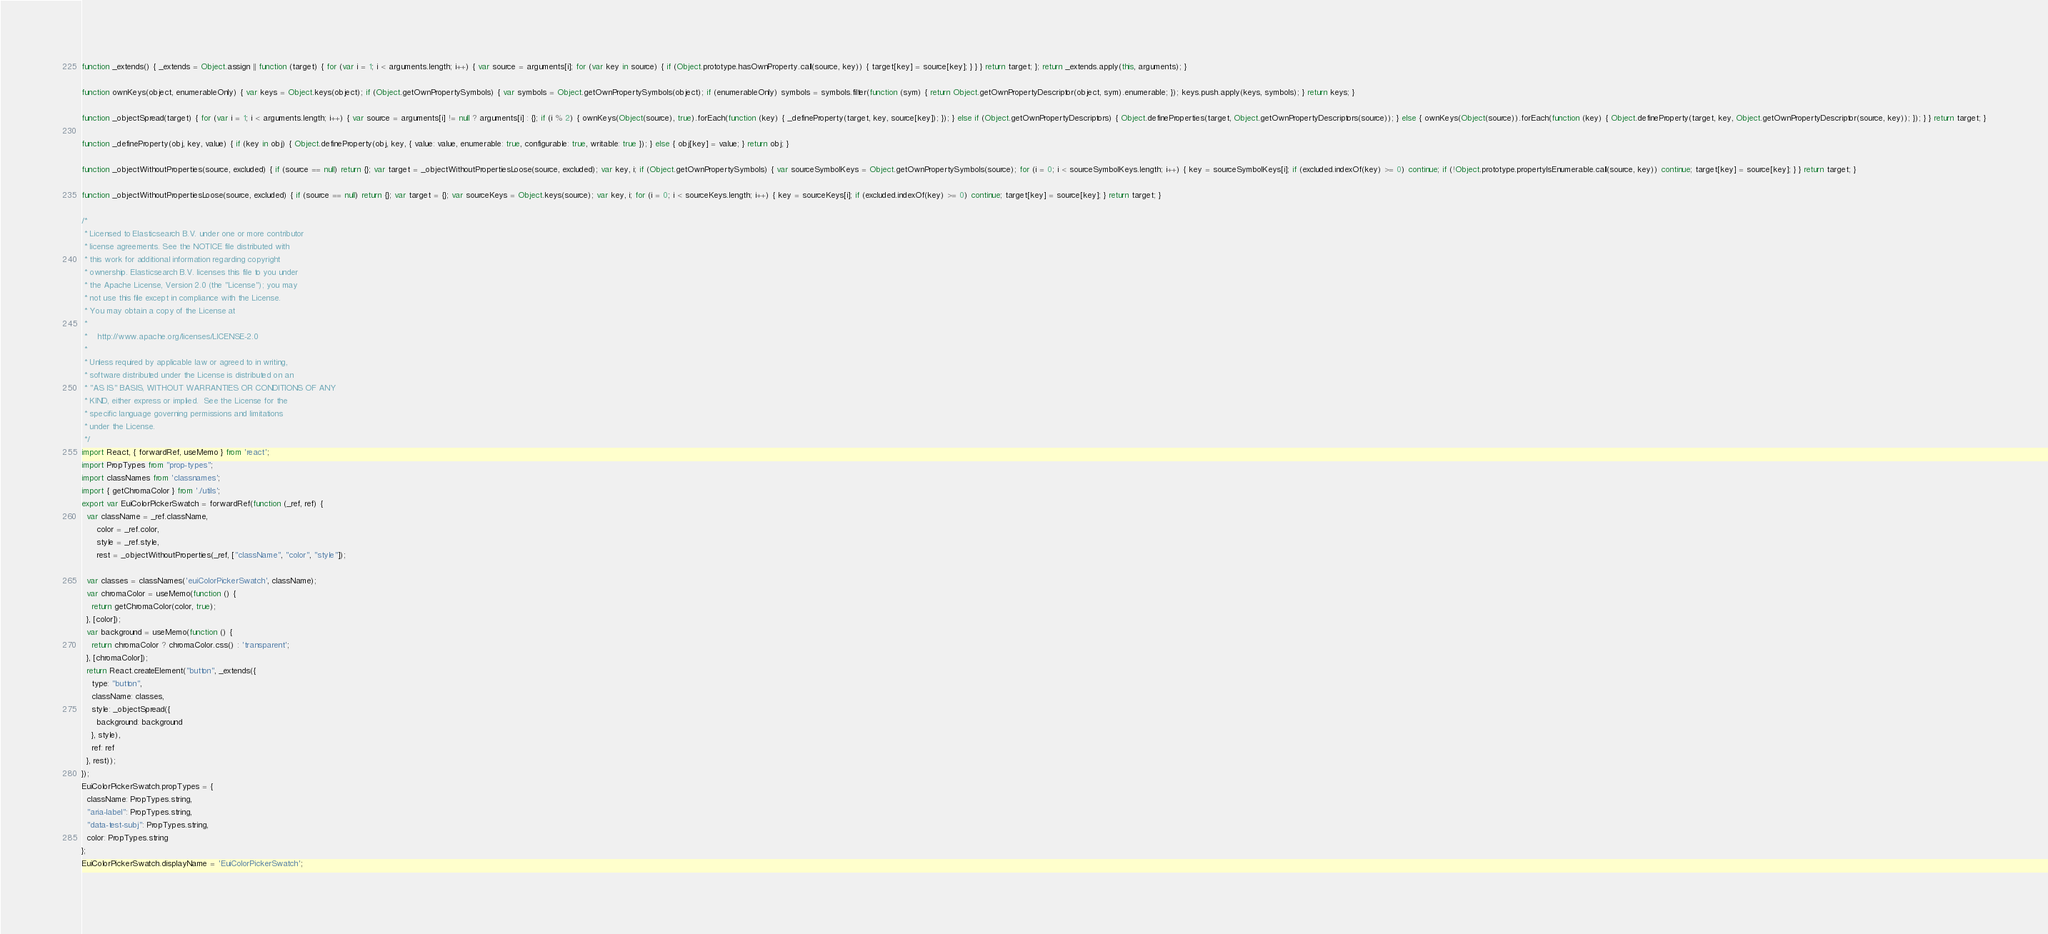<code> <loc_0><loc_0><loc_500><loc_500><_JavaScript_>function _extends() { _extends = Object.assign || function (target) { for (var i = 1; i < arguments.length; i++) { var source = arguments[i]; for (var key in source) { if (Object.prototype.hasOwnProperty.call(source, key)) { target[key] = source[key]; } } } return target; }; return _extends.apply(this, arguments); }

function ownKeys(object, enumerableOnly) { var keys = Object.keys(object); if (Object.getOwnPropertySymbols) { var symbols = Object.getOwnPropertySymbols(object); if (enumerableOnly) symbols = symbols.filter(function (sym) { return Object.getOwnPropertyDescriptor(object, sym).enumerable; }); keys.push.apply(keys, symbols); } return keys; }

function _objectSpread(target) { for (var i = 1; i < arguments.length; i++) { var source = arguments[i] != null ? arguments[i] : {}; if (i % 2) { ownKeys(Object(source), true).forEach(function (key) { _defineProperty(target, key, source[key]); }); } else if (Object.getOwnPropertyDescriptors) { Object.defineProperties(target, Object.getOwnPropertyDescriptors(source)); } else { ownKeys(Object(source)).forEach(function (key) { Object.defineProperty(target, key, Object.getOwnPropertyDescriptor(source, key)); }); } } return target; }

function _defineProperty(obj, key, value) { if (key in obj) { Object.defineProperty(obj, key, { value: value, enumerable: true, configurable: true, writable: true }); } else { obj[key] = value; } return obj; }

function _objectWithoutProperties(source, excluded) { if (source == null) return {}; var target = _objectWithoutPropertiesLoose(source, excluded); var key, i; if (Object.getOwnPropertySymbols) { var sourceSymbolKeys = Object.getOwnPropertySymbols(source); for (i = 0; i < sourceSymbolKeys.length; i++) { key = sourceSymbolKeys[i]; if (excluded.indexOf(key) >= 0) continue; if (!Object.prototype.propertyIsEnumerable.call(source, key)) continue; target[key] = source[key]; } } return target; }

function _objectWithoutPropertiesLoose(source, excluded) { if (source == null) return {}; var target = {}; var sourceKeys = Object.keys(source); var key, i; for (i = 0; i < sourceKeys.length; i++) { key = sourceKeys[i]; if (excluded.indexOf(key) >= 0) continue; target[key] = source[key]; } return target; }

/*
 * Licensed to Elasticsearch B.V. under one or more contributor
 * license agreements. See the NOTICE file distributed with
 * this work for additional information regarding copyright
 * ownership. Elasticsearch B.V. licenses this file to you under
 * the Apache License, Version 2.0 (the "License"); you may
 * not use this file except in compliance with the License.
 * You may obtain a copy of the License at
 *
 *    http://www.apache.org/licenses/LICENSE-2.0
 *
 * Unless required by applicable law or agreed to in writing,
 * software distributed under the License is distributed on an
 * "AS IS" BASIS, WITHOUT WARRANTIES OR CONDITIONS OF ANY
 * KIND, either express or implied.  See the License for the
 * specific language governing permissions and limitations
 * under the License.
 */
import React, { forwardRef, useMemo } from 'react';
import PropTypes from "prop-types";
import classNames from 'classnames';
import { getChromaColor } from './utils';
export var EuiColorPickerSwatch = forwardRef(function (_ref, ref) {
  var className = _ref.className,
      color = _ref.color,
      style = _ref.style,
      rest = _objectWithoutProperties(_ref, ["className", "color", "style"]);

  var classes = classNames('euiColorPickerSwatch', className);
  var chromaColor = useMemo(function () {
    return getChromaColor(color, true);
  }, [color]);
  var background = useMemo(function () {
    return chromaColor ? chromaColor.css() : 'transparent';
  }, [chromaColor]);
  return React.createElement("button", _extends({
    type: "button",
    className: classes,
    style: _objectSpread({
      background: background
    }, style),
    ref: ref
  }, rest));
});
EuiColorPickerSwatch.propTypes = {
  className: PropTypes.string,
  "aria-label": PropTypes.string,
  "data-test-subj": PropTypes.string,
  color: PropTypes.string
};
EuiColorPickerSwatch.displayName = 'EuiColorPickerSwatch';</code> 